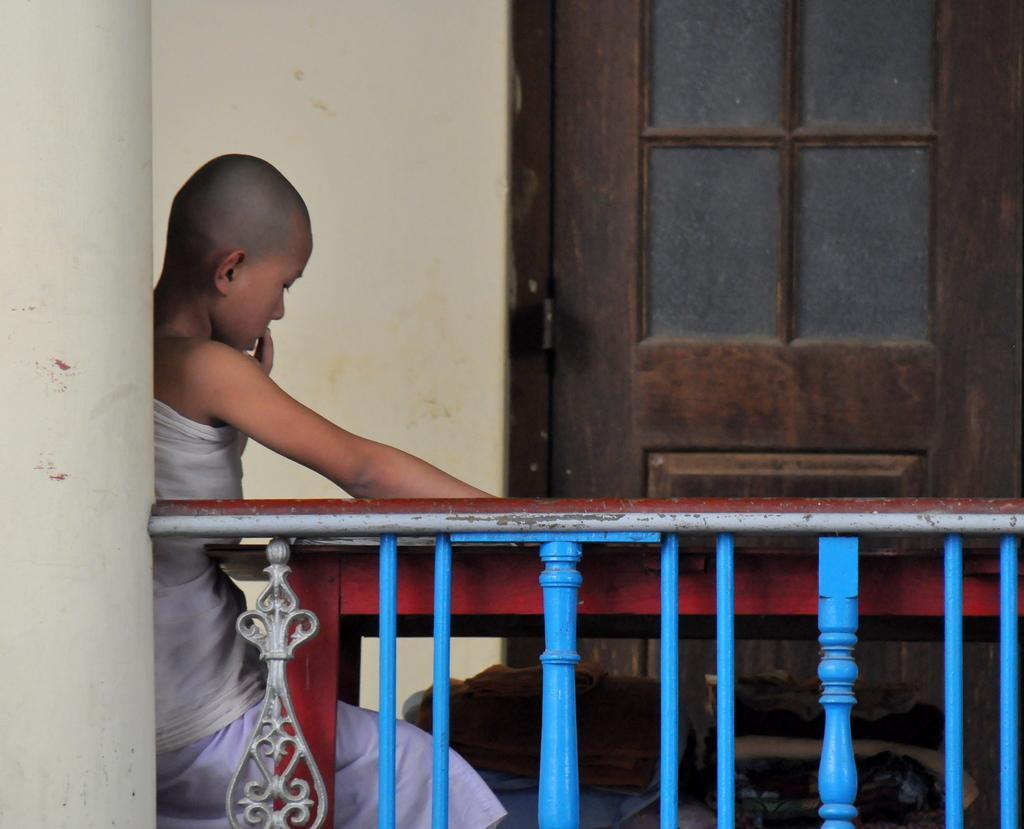Describe this image in one or two sentences. On the left side of the image we can see a pillar and a boy is sitting. In-front of him we can see a table. In the background of the image we can see the wall and door. At the bottom of the image we can see the railing and clothes. 